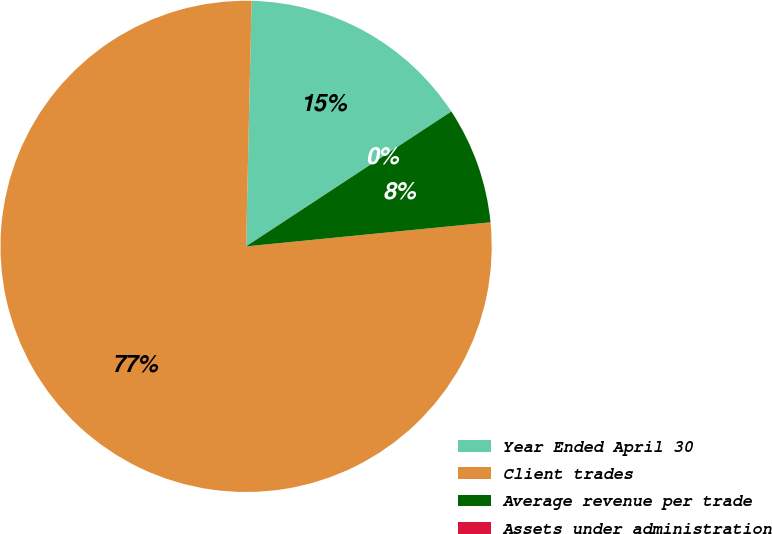Convert chart to OTSL. <chart><loc_0><loc_0><loc_500><loc_500><pie_chart><fcel>Year Ended April 30<fcel>Client trades<fcel>Average revenue per trade<fcel>Assets under administration<nl><fcel>15.39%<fcel>76.92%<fcel>7.69%<fcel>0.0%<nl></chart> 